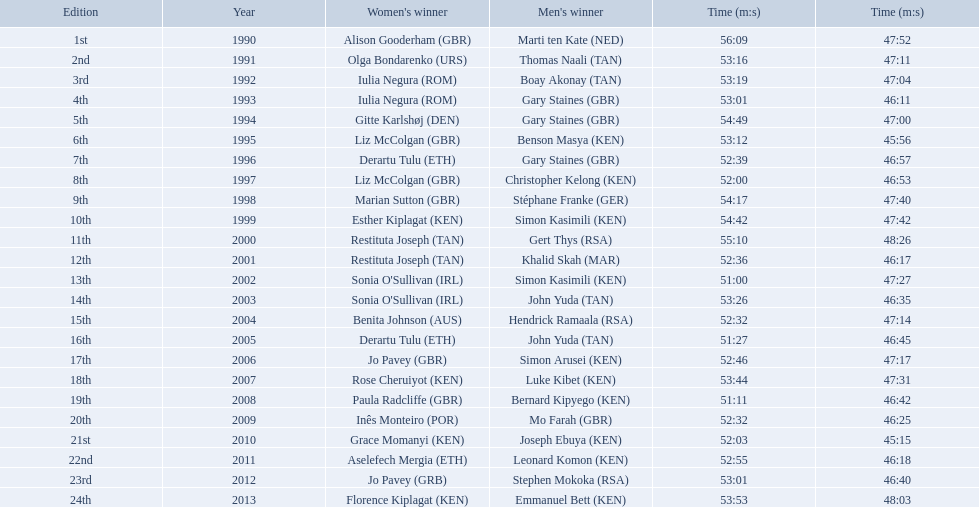What are the names of each male winner? Marti ten Kate (NED), Thomas Naali (TAN), Boay Akonay (TAN), Gary Staines (GBR), Gary Staines (GBR), Benson Masya (KEN), Gary Staines (GBR), Christopher Kelong (KEN), Stéphane Franke (GER), Simon Kasimili (KEN), Gert Thys (RSA), Khalid Skah (MAR), Simon Kasimili (KEN), John Yuda (TAN), Hendrick Ramaala (RSA), John Yuda (TAN), Simon Arusei (KEN), Luke Kibet (KEN), Bernard Kipyego (KEN), Mo Farah (GBR), Joseph Ebuya (KEN), Leonard Komon (KEN), Stephen Mokoka (RSA), Emmanuel Bett (KEN). When did they race? 1990, 1991, 1992, 1993, 1994, 1995, 1996, 1997, 1998, 1999, 2000, 2001, 2002, 2003, 2004, 2005, 2006, 2007, 2008, 2009, 2010, 2011, 2012, 2013. And what were their times? 47:52, 47:11, 47:04, 46:11, 47:00, 45:56, 46:57, 46:53, 47:40, 47:42, 48:26, 46:17, 47:27, 46:35, 47:14, 46:45, 47:17, 47:31, 46:42, 46:25, 45:15, 46:18, 46:40, 48:03. Of those times, which athlete had the fastest time? Joseph Ebuya (KEN). 